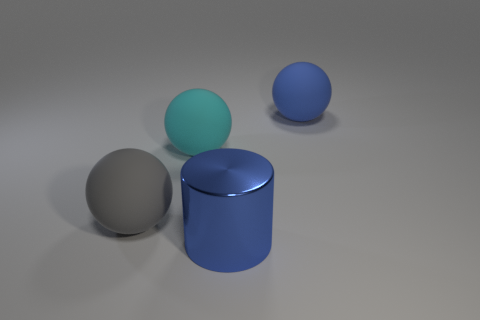Do the objects in the image appear to be made of the same material? The objects in the image do not appear to be made of the same material. The large blue ball and the cylindrical blue object have a reflective, glossy finish, suggesting they could be made of plastic or a similarly polished material. The gray sphere has a dull, matte finish, indicating it might be made of a different material, possibly metal or rubber, that does not reflect light in the same way. 